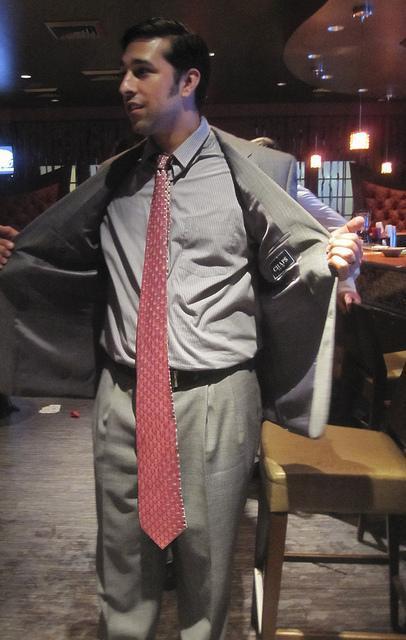How many people are in the photo?
Give a very brief answer. 1. How many chairs are in the picture?
Give a very brief answer. 2. 